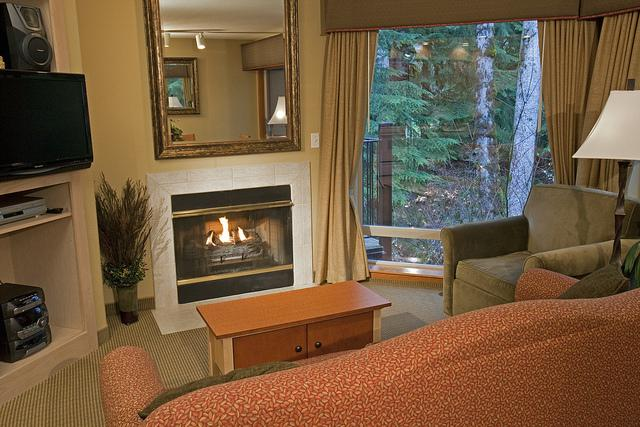What is the most likely floor level for this room?

Choices:
A) first/second
B) fifth/sixth
C) third/fourth
D) seventh/eighth first/second 